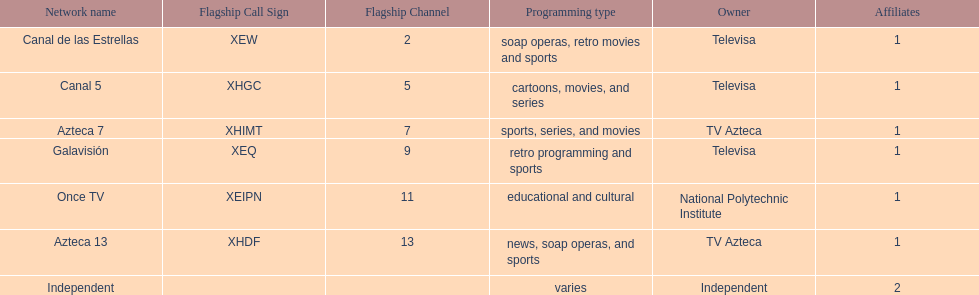How many networks do not air sports? 2. 